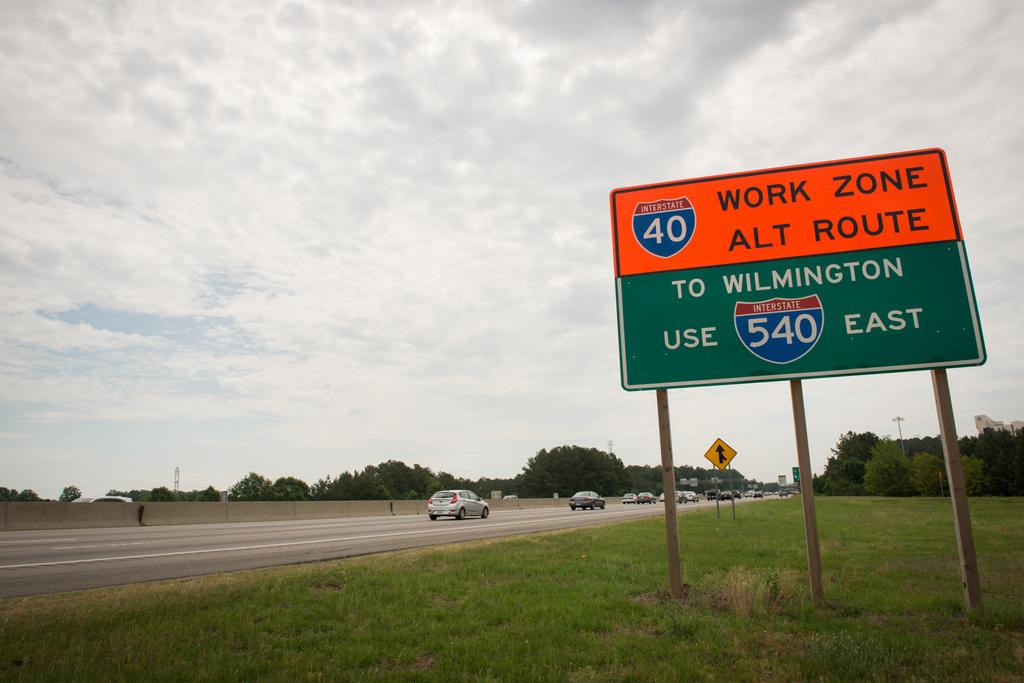Where does interstate 540 lead to?
Your response must be concise. Wilmington. 